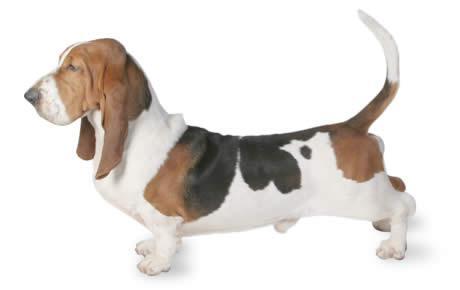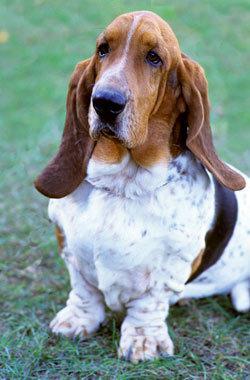The first image is the image on the left, the second image is the image on the right. Assess this claim about the two images: "One image shows a basset in profile on a white background.". Correct or not? Answer yes or no. Yes. 